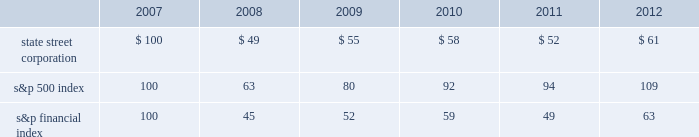Shareholder return performance presentation the graph presented below compares the cumulative total shareholder return on state street's common stock to the cumulative total return of the s&p 500 index and the s&p financial index over a five-year period .
The cumulative total shareholder return assumes the investment of $ 100 in state street common stock and in each index on december 31 , 2007 at the closing price on the last trading day of 2007 , and also assumes reinvestment of common stock dividends .
The s&p financial index is a publicly available measure of 80 of the standard & poor's 500 companies , representing 26 diversified financial services companies , 22 insurance companies , 17 real estate companies and 15 banking companies .
Comparison of five-year cumulative total shareholder return .

What is the percent change in state street corporation's cumulative total shareholder return on common stock between 2008 and 2009? 
Computations: ((55 - 49) / 49)
Answer: 0.12245. 